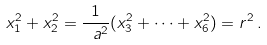<formula> <loc_0><loc_0><loc_500><loc_500>x _ { 1 } ^ { 2 } + x _ { 2 } ^ { 2 } = \frac { 1 } { \ a ^ { 2 } } ( x _ { 3 } ^ { 2 } + \cdots + x _ { 6 } ^ { 2 } ) = r ^ { 2 } \, .</formula> 